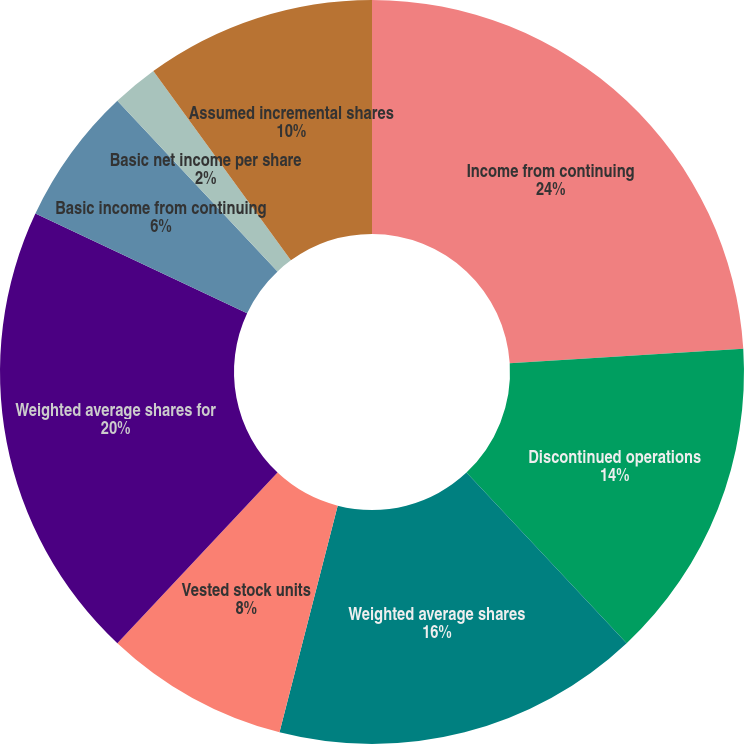Convert chart. <chart><loc_0><loc_0><loc_500><loc_500><pie_chart><fcel>Income from continuing<fcel>Discontinued operations<fcel>Weighted average shares<fcel>Vested stock units<fcel>Weighted average shares for<fcel>Basic income from continuing<fcel>Basic net income per share<fcel>Assumed incremental shares<nl><fcel>24.0%<fcel>14.0%<fcel>16.0%<fcel>8.0%<fcel>20.0%<fcel>6.0%<fcel>2.0%<fcel>10.0%<nl></chart> 